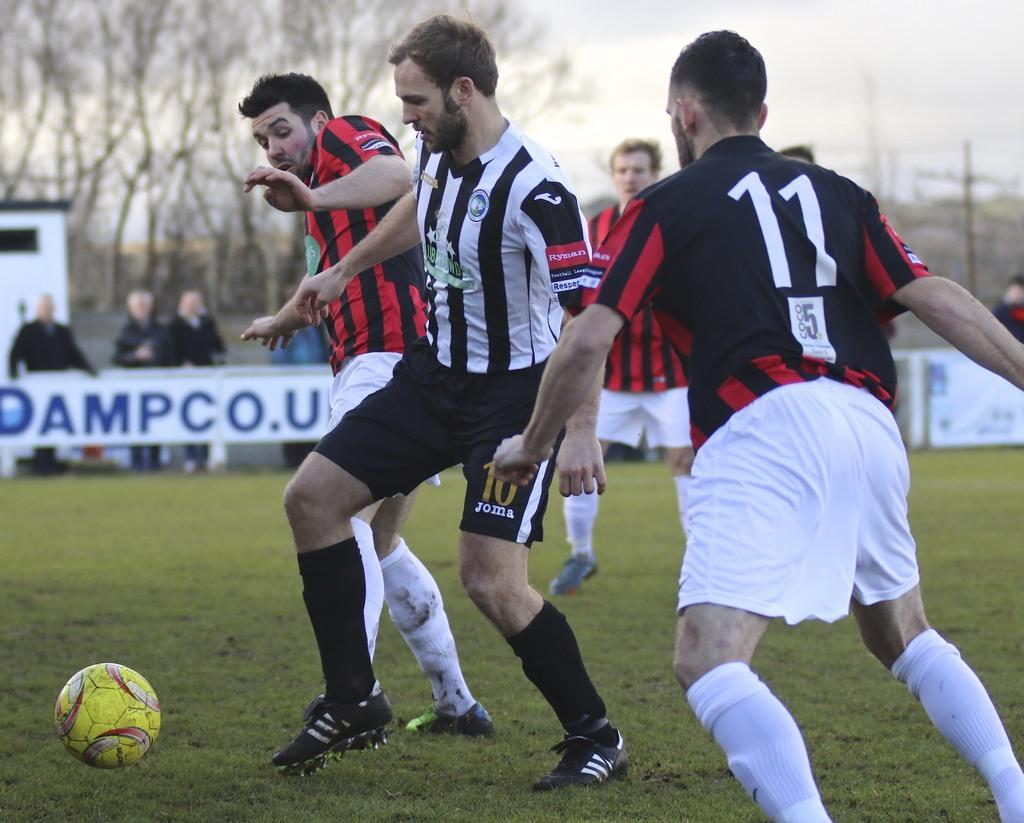<image>
Summarize the visual content of the image. Player number 11 is running toward the ball and some other players. 